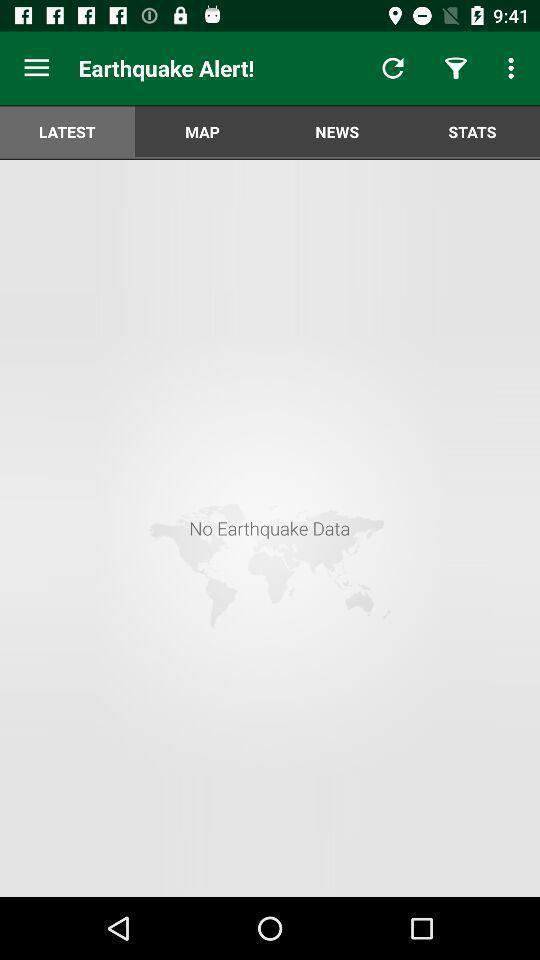What can you discern from this picture? Screen page of a real time alerts of earthquake application. 